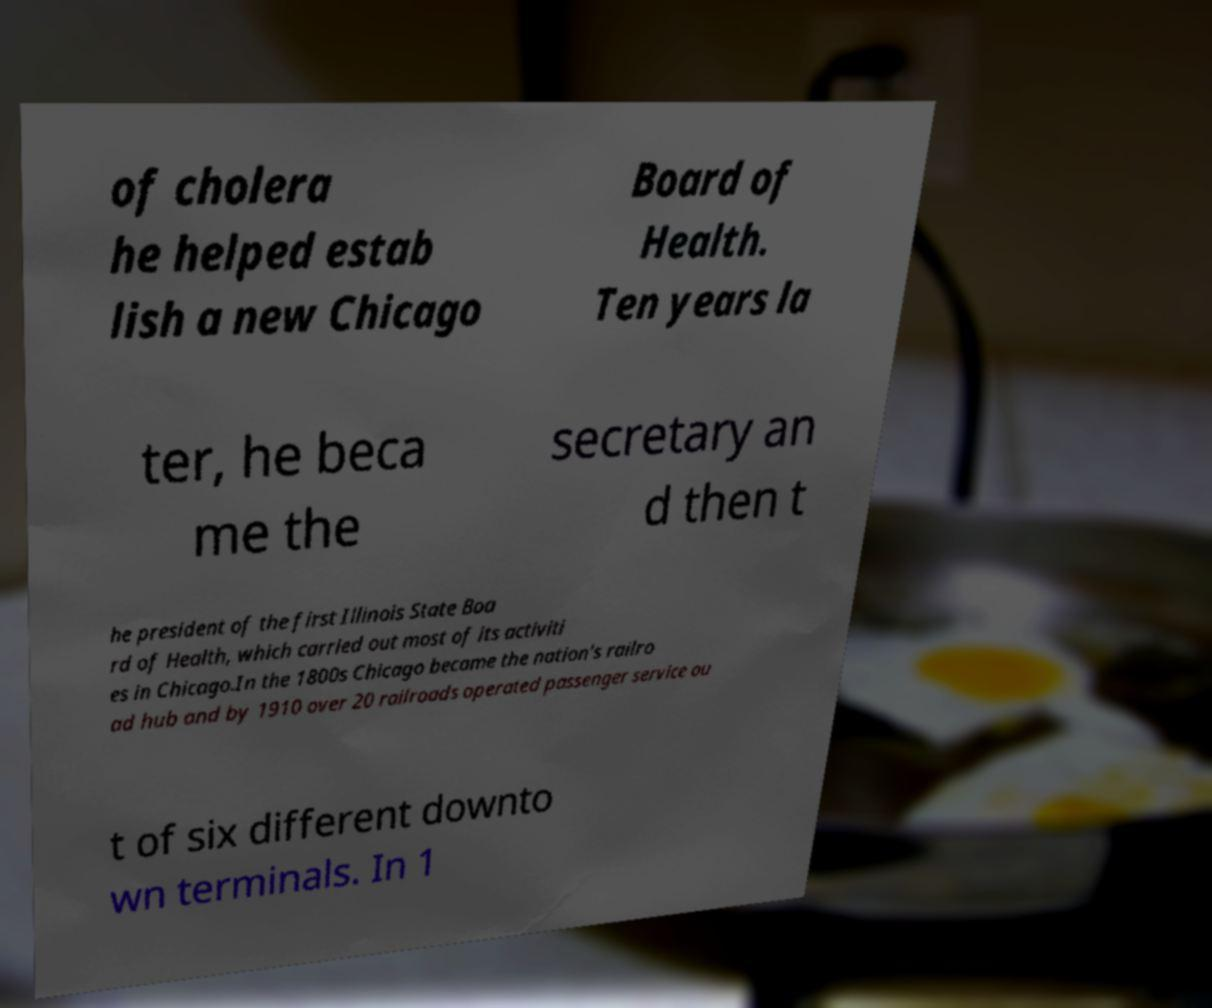Please identify and transcribe the text found in this image. of cholera he helped estab lish a new Chicago Board of Health. Ten years la ter, he beca me the secretary an d then t he president of the first Illinois State Boa rd of Health, which carried out most of its activiti es in Chicago.In the 1800s Chicago became the nation's railro ad hub and by 1910 over 20 railroads operated passenger service ou t of six different downto wn terminals. In 1 